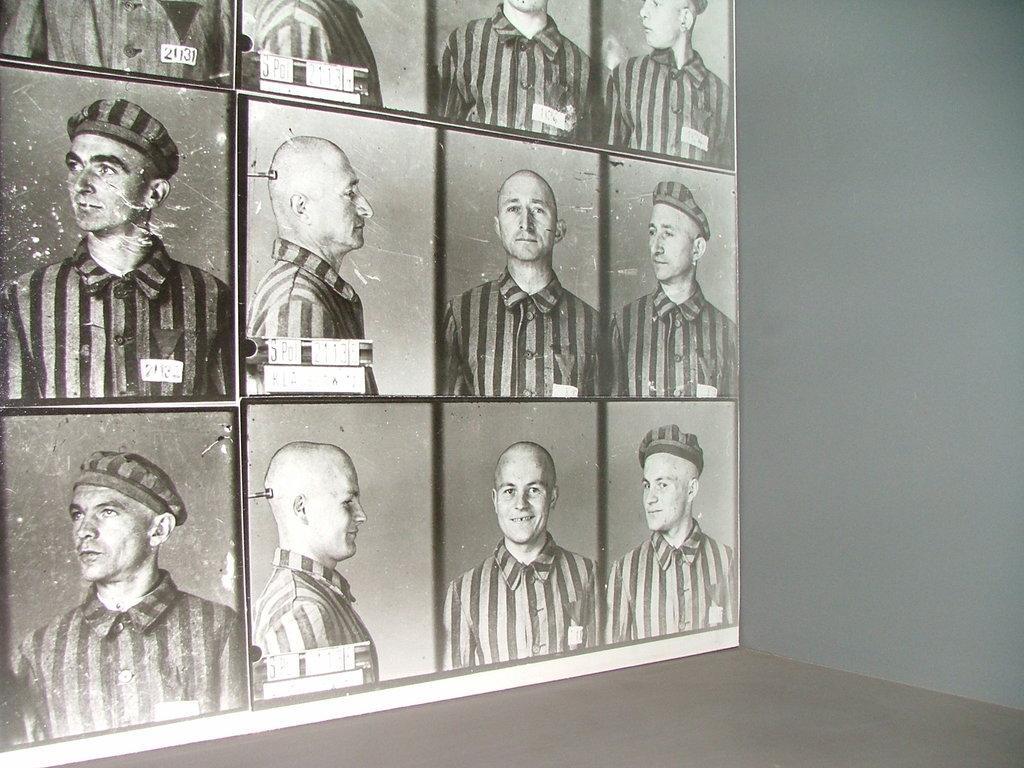Can you describe this image briefly? In this picture I can see few black and white images of few men in the left side and I can see wall. 